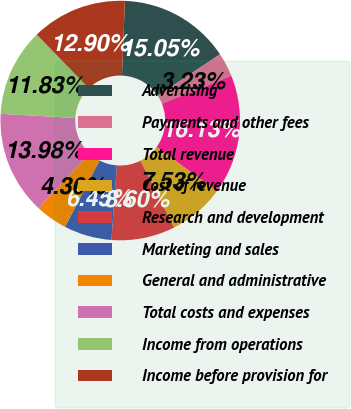Convert chart. <chart><loc_0><loc_0><loc_500><loc_500><pie_chart><fcel>Advertising<fcel>Payments and other fees<fcel>Total revenue<fcel>Cost of revenue<fcel>Research and development<fcel>Marketing and sales<fcel>General and administrative<fcel>Total costs and expenses<fcel>Income from operations<fcel>Income before provision for<nl><fcel>15.05%<fcel>3.23%<fcel>16.13%<fcel>7.53%<fcel>8.6%<fcel>6.45%<fcel>4.3%<fcel>13.98%<fcel>11.83%<fcel>12.9%<nl></chart> 